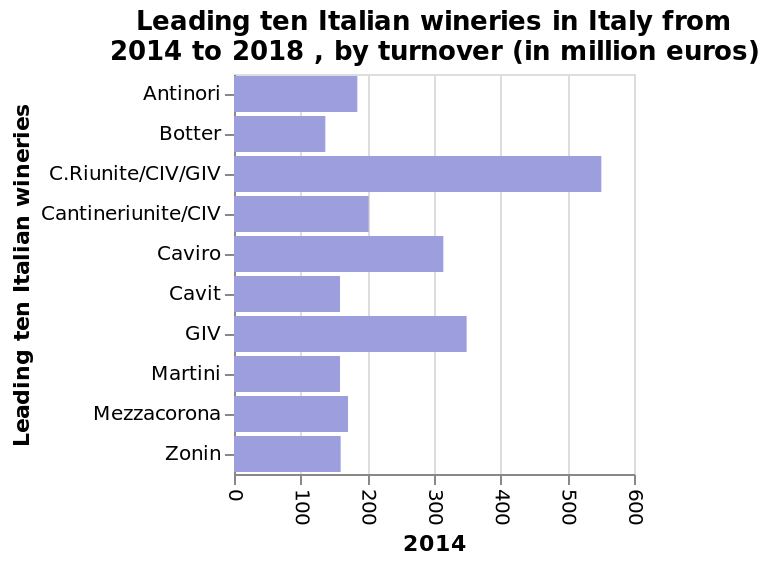<image>
Which year is represented on the x-axis? 2014 What is the unit of measurement for the turnover data? Million euros What is the time frame for the Italian winners with the highest turnover? The time frame is from 2014 to 2018 for the Italian winners with the highest turnover. 